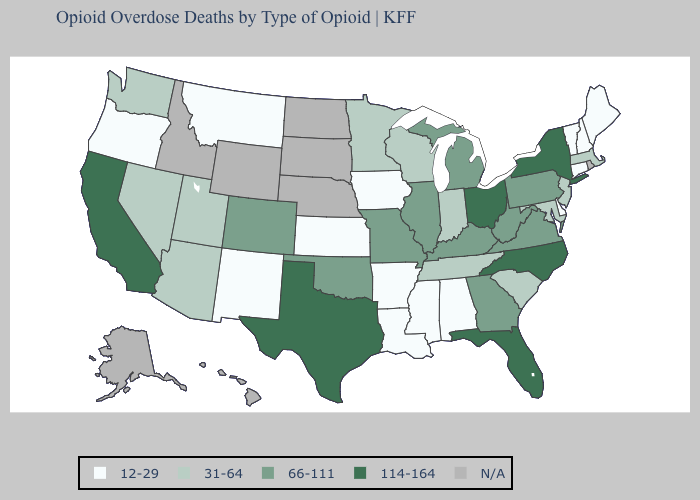Which states have the lowest value in the USA?
Answer briefly. Alabama, Arkansas, Connecticut, Delaware, Iowa, Kansas, Louisiana, Maine, Mississippi, Montana, New Hampshire, New Mexico, Oregon, Vermont. Does New York have the lowest value in the Northeast?
Concise answer only. No. Among the states that border Nebraska , which have the highest value?
Answer briefly. Colorado, Missouri. Name the states that have a value in the range 66-111?
Answer briefly. Colorado, Georgia, Illinois, Kentucky, Michigan, Missouri, Oklahoma, Pennsylvania, Virginia, West Virginia. Among the states that border Illinois , which have the highest value?
Write a very short answer. Kentucky, Missouri. Which states have the highest value in the USA?
Short answer required. California, Florida, New York, North Carolina, Ohio, Texas. What is the lowest value in states that border Kentucky?
Keep it brief. 31-64. Which states have the highest value in the USA?
Quick response, please. California, Florida, New York, North Carolina, Ohio, Texas. What is the value of Missouri?
Give a very brief answer. 66-111. Name the states that have a value in the range 31-64?
Answer briefly. Arizona, Indiana, Maryland, Massachusetts, Minnesota, Nevada, New Jersey, South Carolina, Tennessee, Utah, Washington, Wisconsin. What is the value of New Jersey?
Give a very brief answer. 31-64. Name the states that have a value in the range 114-164?
Concise answer only. California, Florida, New York, North Carolina, Ohio, Texas. Which states have the lowest value in the West?
Give a very brief answer. Montana, New Mexico, Oregon. 